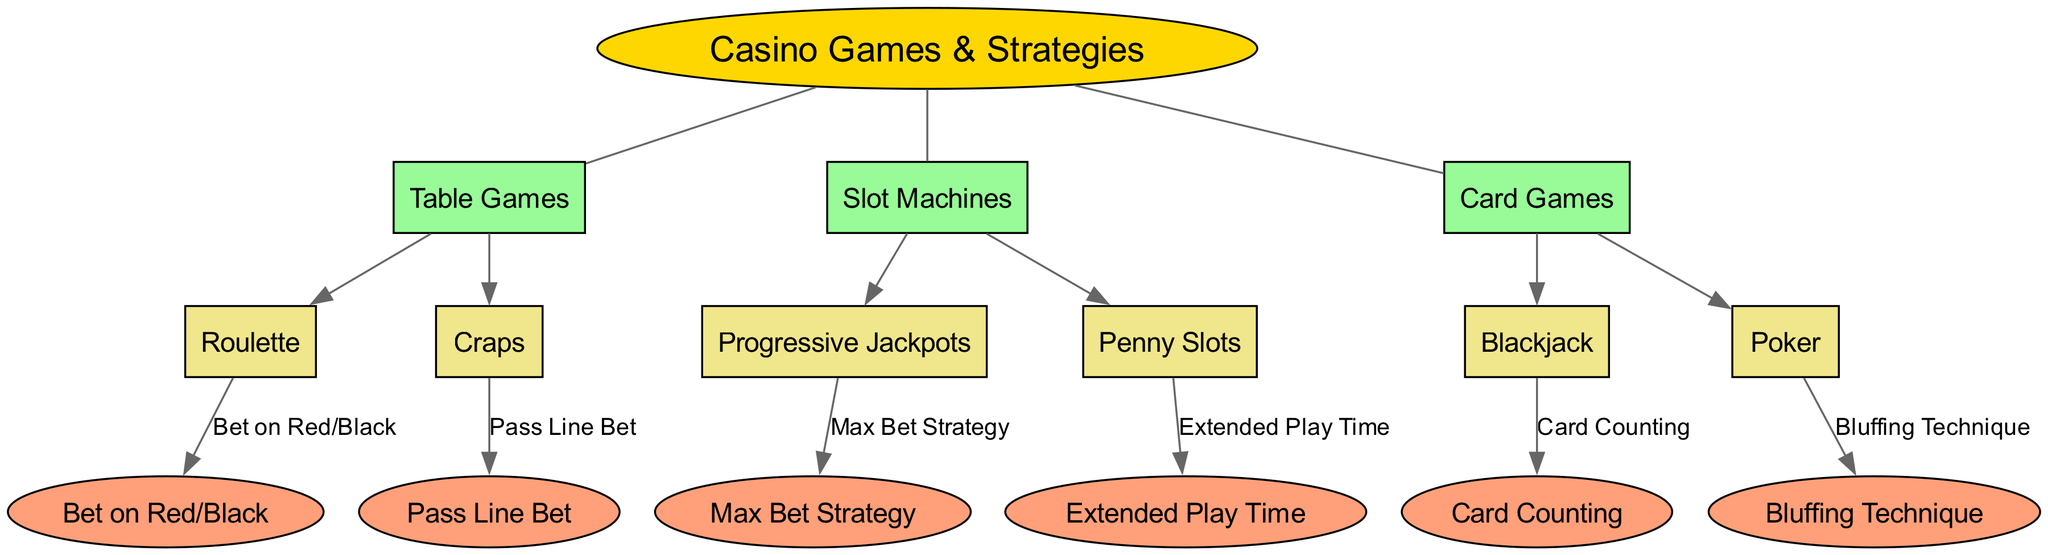What is the central concept of the diagram? The central concept, which is the main topic discussed in the diagram, is presented in an ellipse at the center. According to the provided data, this concept is "Casino Games & Strategies."
Answer: Casino Games & Strategies How many main categories are there? The main categories are listed as "Table Games," "Slot Machines," and "Card Games." Counting these main categories from the data shows that there are three in total.
Answer: 3 What game is associated with the "Pass Line Bet"? By tracing the connections in the diagram, the "Pass Line Bet" is connected directly to the game "Craps." This indicates that this betting strategy is specific to Craps.
Answer: Craps Which category includes "Blackjack"? The categories presented in the diagram show that "Blackjack" is a part of the "Card Games" category. This can be seen from the direct connection from "Card Games" to "Blackjack."
Answer: Card Games What strategy is linked to "Penny Slots"? In the diagram, "Penny Slots" connects to the strategy called "Extended Play Time." This means the strategy is used in relation to playing Penny Slots.
Answer: Extended Play Time Which game is linked with the strategy "Bluffing Technique"? The connection from the "Poker" category shows that "Bluffing Technique" is the strategy associated with this card game. Thus, this strategy is specifically utilized in Poker.
Answer: Poker What are the two main types of Table Games mentioned? As per the relationships defined in the diagram, "Table Games" includes two key games: "Roulette" and "Craps." Both these games are directly linked under the "Table Games" category.
Answer: Roulette, Craps What is the strategy for "Progressive Jackpots"? The strategy connected to "Progressive Jackpots" is the "Max Bet Strategy," indicating that to maximize winnings on these slots, players should use this strategy.
Answer: Max Bet Strategy How is "Card Counting" related to "Blackjack"? The connection between "Blackjack" and "Card Counting" indicates that this strategic approach is often employed by players of Blackjack to gain an advantage in the game.
Answer: Card Counting 